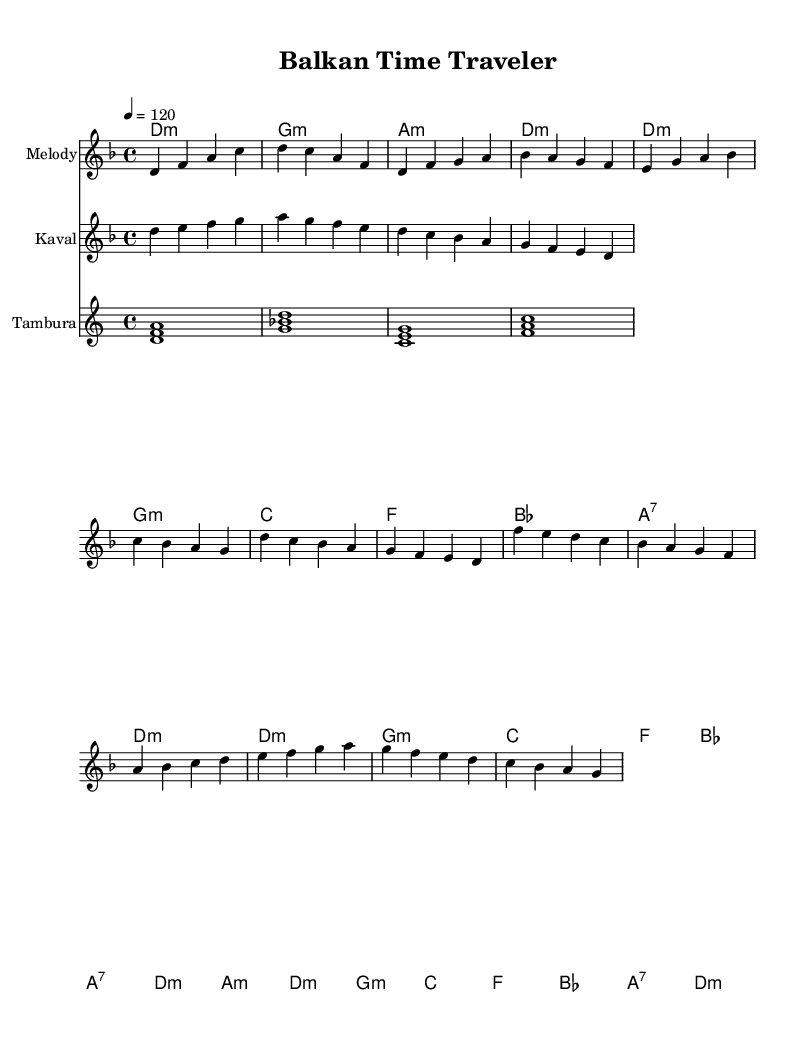What is the key signature of this music? The key signature is D minor, which is indicated by the two flats, B and E, following the clef.
Answer: D minor What is the time signature of this music? The time signature is indicated as 4/4, meaning there are four beats per measure and the quarter note gets one beat.
Answer: 4/4 What is the tempo marking for this piece? The tempo marking is indicated at the beginning of the score, showing a speed of 120 beats per minute, denoted as “4 = 120.”
Answer: 120 How many measures are in the chorus section? Counting the measures in the chorus, there are a total of 8 measures dedicated to the chorus lyrics as evident from the layout.
Answer: 8 What type of instruments are featured in this score? The score features a melody, kaval, and tambura, each indicated as separate staves. The inclusion of these traditional Balkan instruments shows a fusion with modern disco elements.
Answer: Melody, Kaval, Tambura In which section do the lyrics mention "migration and cultures intertwine"? This phrase appears in the chorus lyrics, highlighting the anthropological themes that blend with the disco rhythm.
Answer: Chorus What is the last chord of the bridge section? The last chord of the bridge section is D minor, as identified from the harmonies written at the end of that segment.
Answer: D minor 